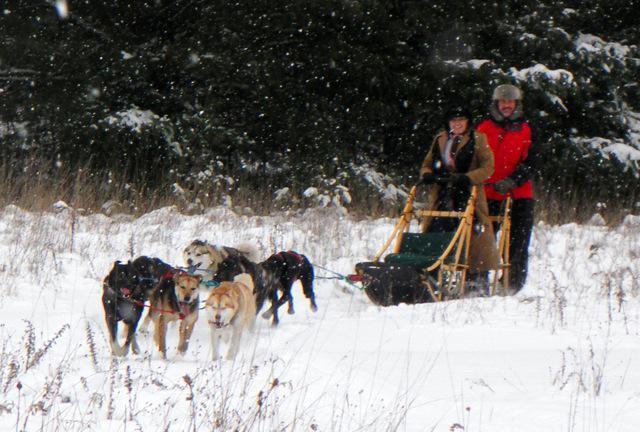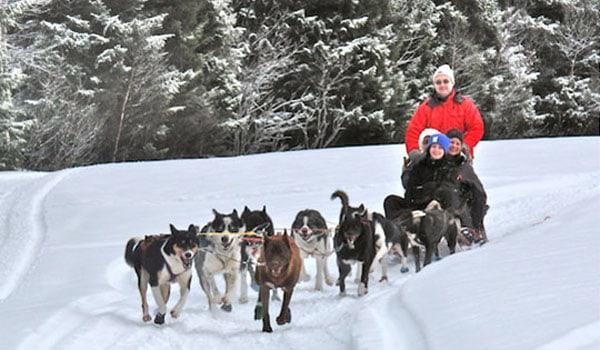The first image is the image on the left, the second image is the image on the right. Considering the images on both sides, is "The dog-pulled sleds in the left and right images move forward over snow at a leftward angle." valid? Answer yes or no. Yes. 